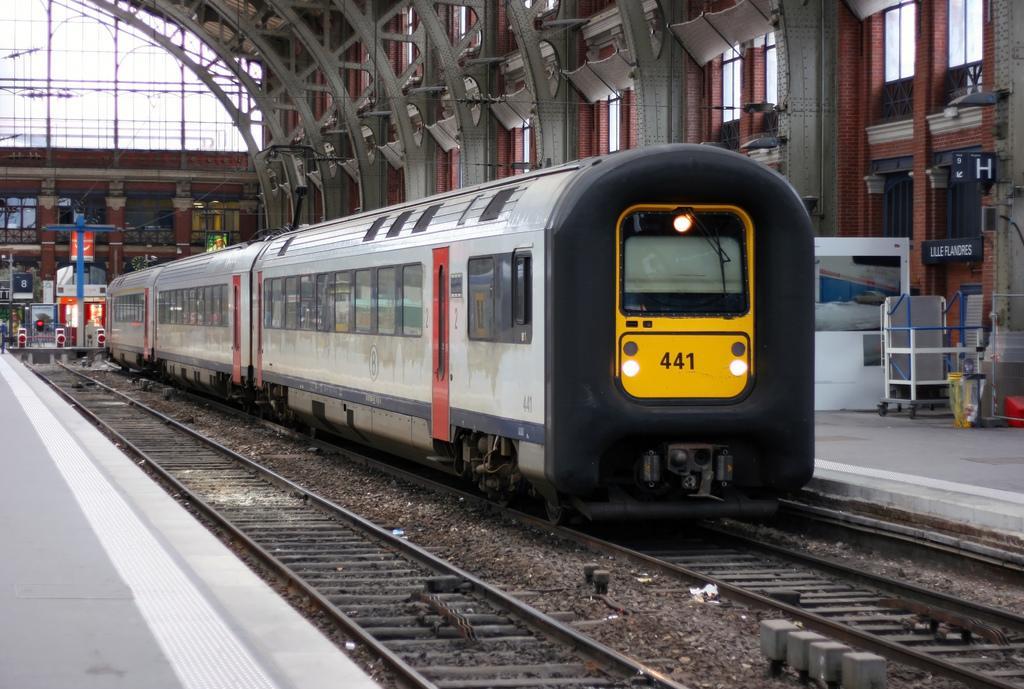Could you give a brief overview of what you see in this image? In this picture I can see a train on the railway track, there are platforms, trolley, boards, cables, windows, there is another railway track and there are some other items. 